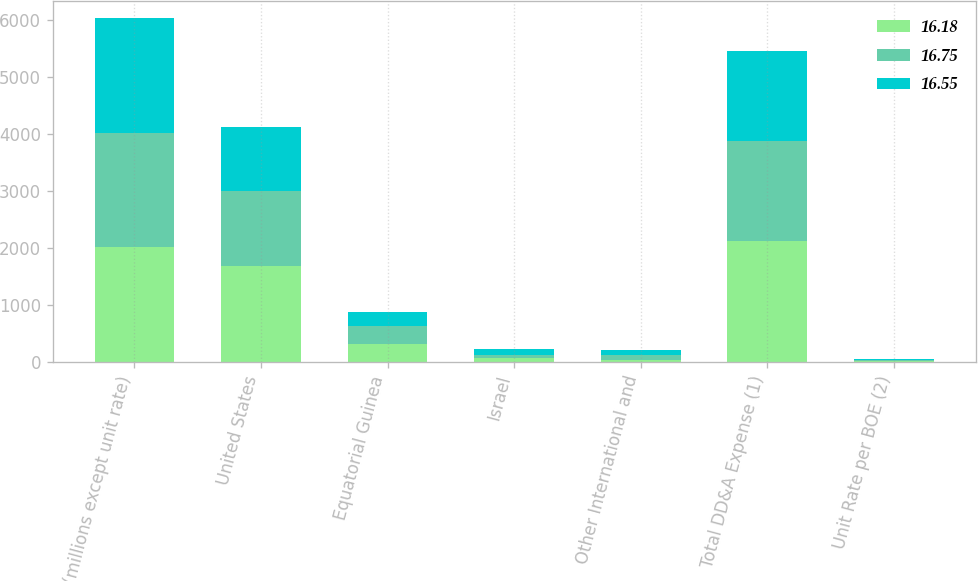Convert chart to OTSL. <chart><loc_0><loc_0><loc_500><loc_500><stacked_bar_chart><ecel><fcel>(millions except unit rate)<fcel>United States<fcel>Equatorial Guinea<fcel>Israel<fcel>Other International and<fcel>Total DD&A Expense (1)<fcel>Unit Rate per BOE (2)<nl><fcel>16.18<fcel>2015<fcel>1692<fcel>326<fcel>70<fcel>43<fcel>2131<fcel>16.75<nl><fcel>16.75<fcel>2014<fcel>1318<fcel>299<fcel>63<fcel>79<fcel>1759<fcel>16.55<nl><fcel>16.55<fcel>2013<fcel>1117<fcel>261<fcel>97<fcel>93<fcel>1568<fcel>16.18<nl></chart> 